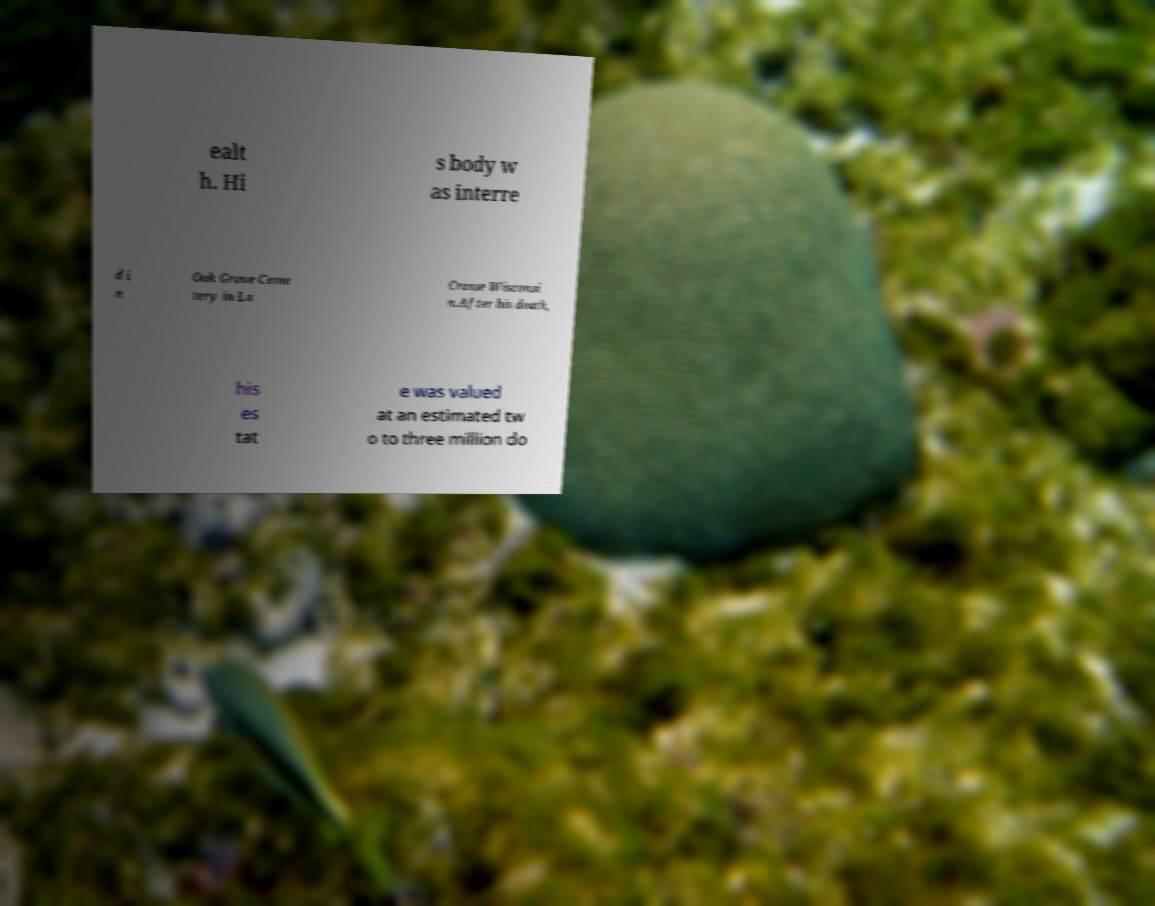There's text embedded in this image that I need extracted. Can you transcribe it verbatim? ealt h. Hi s body w as interre d i n Oak Grove Ceme tery in La Crosse Wisconsi n.After his death, his es tat e was valued at an estimated tw o to three million do 